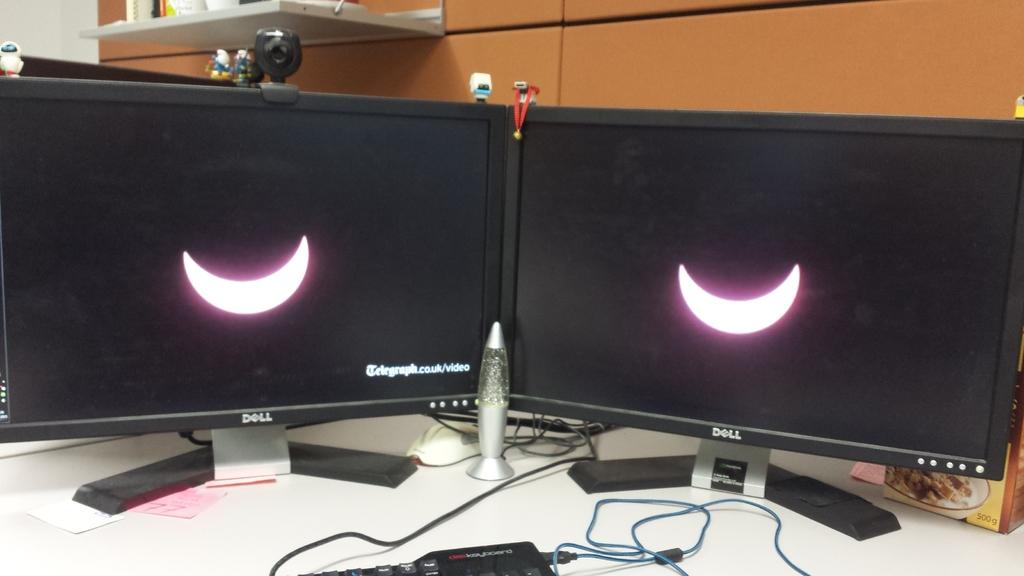Provide a one-sentence caption for the provided image. Two Dell monitors show either a crescent moon or a solar eclipse. 